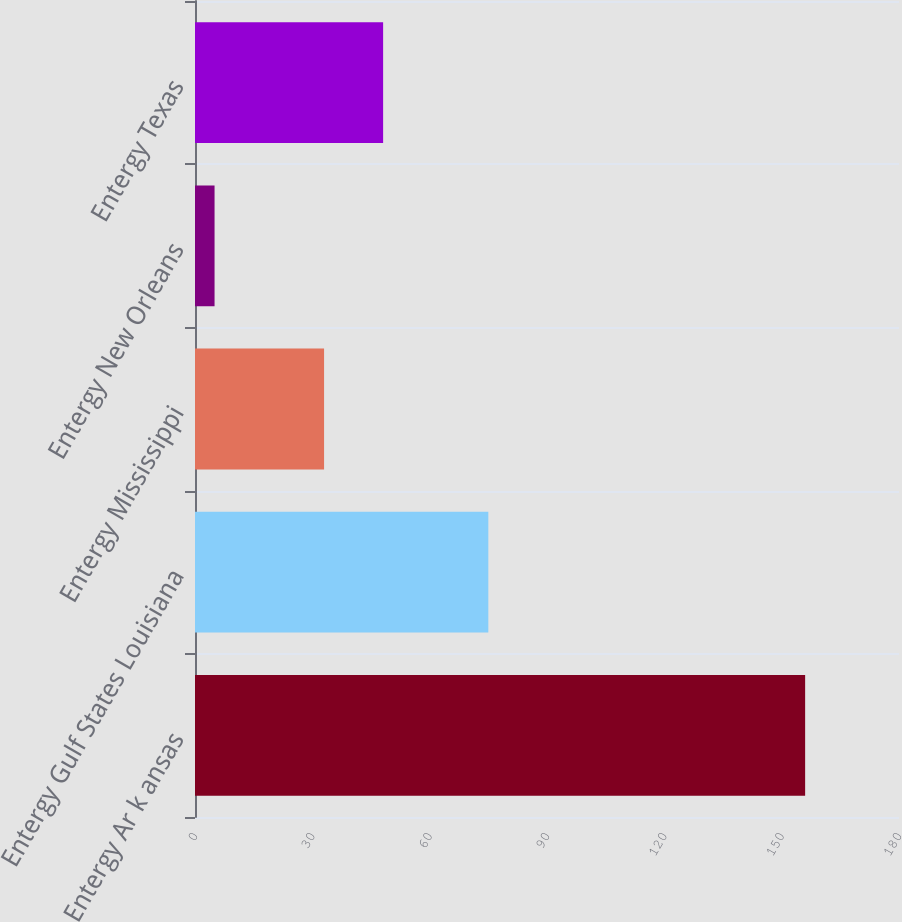Convert chart. <chart><loc_0><loc_0><loc_500><loc_500><bar_chart><fcel>Entergy Ar k ansas<fcel>Entergy Gulf States Louisiana<fcel>Entergy Mississippi<fcel>Entergy New Orleans<fcel>Entergy Texas<nl><fcel>156<fcel>75<fcel>33<fcel>5<fcel>48.1<nl></chart> 